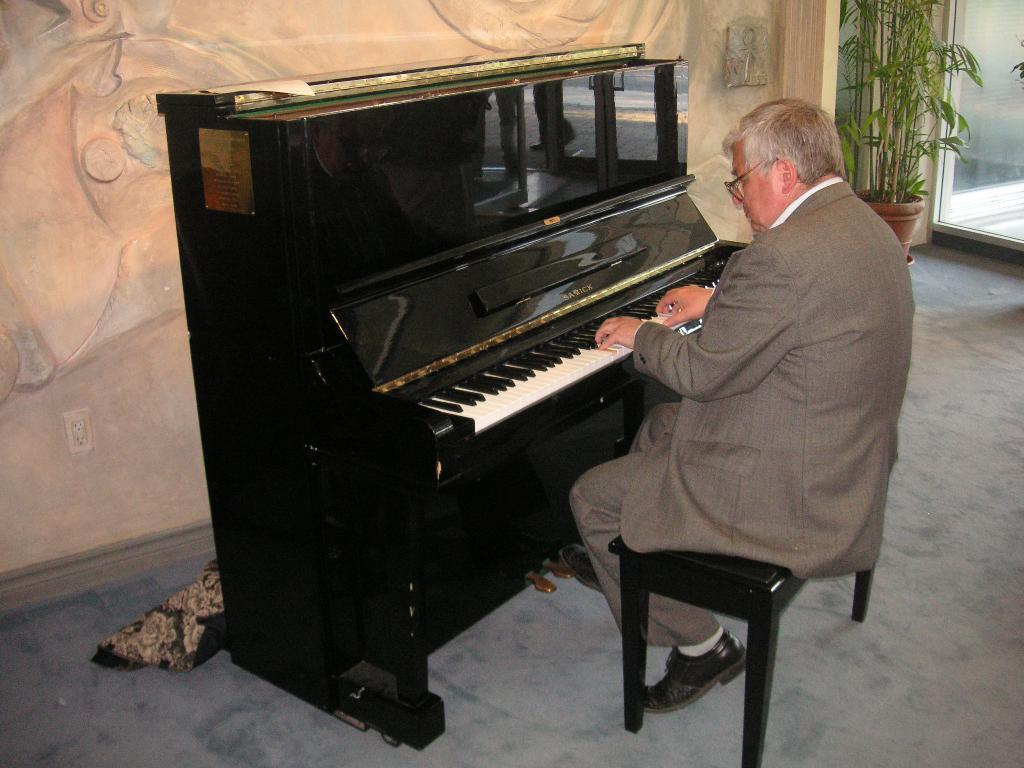What is the person in the image doing? The person is playing the piano. Where is the person sitting while playing the piano? The person is sitting on a bench. What can be seen to the right of the bench? There is a flower pot to the right of the bench. What is visible in the background of the image? There is a wall in the background of the image. What type of minister is standing next to the piano in the image? There is no minister present in the image; the person is playing the piano alone on a bench. 